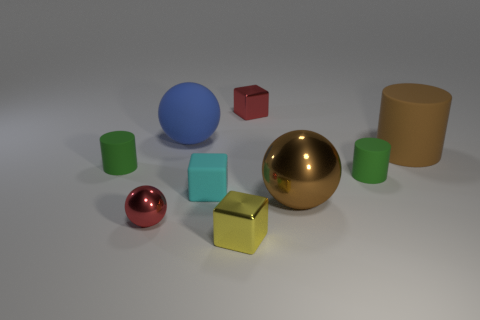What is the shape of the thing that is the same color as the small ball?
Your answer should be very brief. Cube. What number of things are either tiny cyan matte cubes in front of the brown matte cylinder or red metallic spheres?
Your response must be concise. 2. Are there fewer big cyan cylinders than matte blocks?
Keep it short and to the point. Yes. What shape is the cyan thing that is made of the same material as the big blue thing?
Provide a short and direct response. Cube. There is a red metal sphere; are there any matte cylinders on the left side of it?
Provide a succinct answer. Yes. Are there fewer matte objects that are behind the small yellow metallic cube than brown objects?
Give a very brief answer. No. What is the tiny yellow block made of?
Ensure brevity in your answer.  Metal. What color is the large cylinder?
Your response must be concise. Brown. What is the color of the large thing that is both behind the brown sphere and to the right of the tiny cyan matte cube?
Keep it short and to the point. Brown. Is there any other thing that has the same material as the blue object?
Your answer should be compact. Yes. 